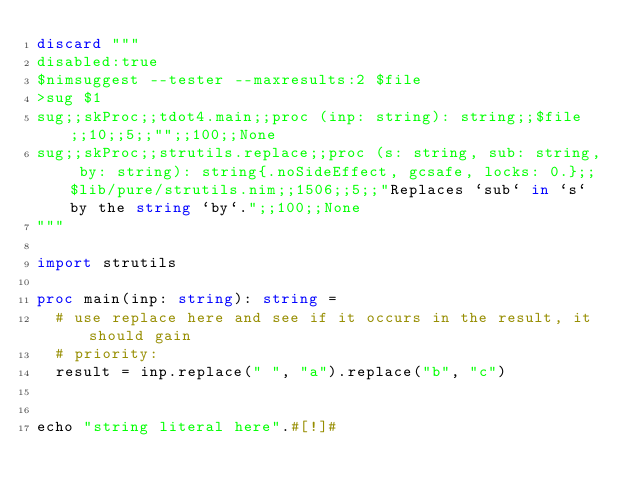Convert code to text. <code><loc_0><loc_0><loc_500><loc_500><_Nim_>discard """
disabled:true
$nimsuggest --tester --maxresults:2 $file
>sug $1
sug;;skProc;;tdot4.main;;proc (inp: string): string;;$file;;10;;5;;"";;100;;None
sug;;skProc;;strutils.replace;;proc (s: string, sub: string, by: string): string{.noSideEffect, gcsafe, locks: 0.};;$lib/pure/strutils.nim;;1506;;5;;"Replaces `sub` in `s` by the string `by`.";;100;;None
"""

import strutils

proc main(inp: string): string =
  # use replace here and see if it occurs in the result, it should gain
  # priority:
  result = inp.replace(" ", "a").replace("b", "c")


echo "string literal here".#[!]#
</code> 